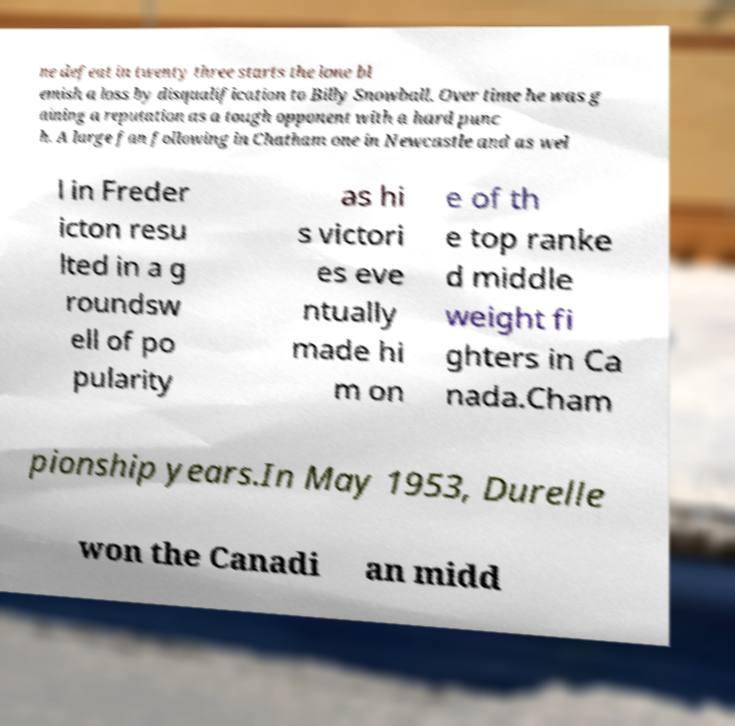Please identify and transcribe the text found in this image. ne defeat in twenty three starts the lone bl emish a loss by disqualification to Billy Snowball. Over time he was g aining a reputation as a tough opponent with a hard punc h. A large fan following in Chatham one in Newcastle and as wel l in Freder icton resu lted in a g roundsw ell of po pularity as hi s victori es eve ntually made hi m on e of th e top ranke d middle weight fi ghters in Ca nada.Cham pionship years.In May 1953, Durelle won the Canadi an midd 